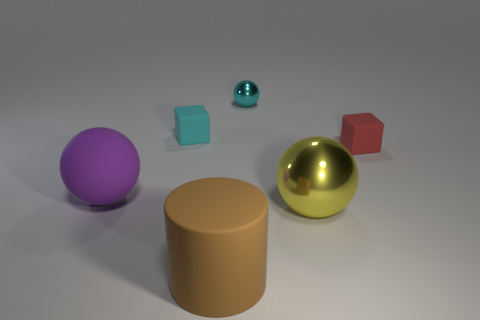Is there anything else that is the same shape as the brown object?
Provide a succinct answer. No. Are there an equal number of tiny cyan cubes that are on the right side of the large brown rubber thing and small red blocks?
Offer a terse response. No. There is a shiny object in front of the small metallic ball; are there any purple things that are right of it?
Your response must be concise. No. What number of other objects are there of the same color as the big matte sphere?
Provide a short and direct response. 0. The large matte cylinder is what color?
Provide a short and direct response. Brown. What size is the ball that is both on the right side of the big brown thing and behind the large metal sphere?
Give a very brief answer. Small. How many things are tiny things that are to the left of the tiny red thing or large brown objects?
Your answer should be very brief. 3. There is a tiny red thing that is the same material as the purple thing; what is its shape?
Your answer should be very brief. Cube. What is the shape of the large brown matte object?
Give a very brief answer. Cylinder. There is a thing that is both to the left of the cyan shiny object and behind the large purple matte object; what is its color?
Offer a very short reply. Cyan. 